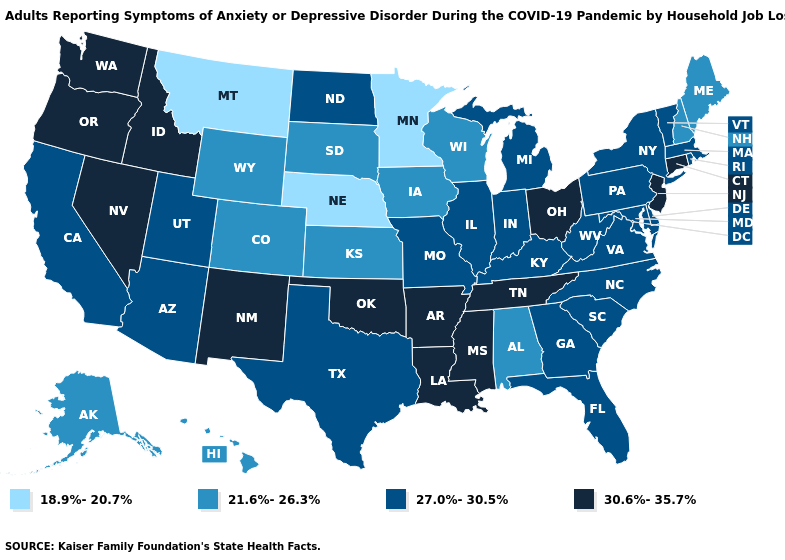Is the legend a continuous bar?
Write a very short answer. No. Name the states that have a value in the range 30.6%-35.7%?
Short answer required. Arkansas, Connecticut, Idaho, Louisiana, Mississippi, Nevada, New Jersey, New Mexico, Ohio, Oklahoma, Oregon, Tennessee, Washington. Does Oklahoma have the same value as Hawaii?
Give a very brief answer. No. How many symbols are there in the legend?
Be succinct. 4. Does Arkansas have a higher value than Kentucky?
Write a very short answer. Yes. Among the states that border Iowa , which have the highest value?
Give a very brief answer. Illinois, Missouri. Which states have the highest value in the USA?
Answer briefly. Arkansas, Connecticut, Idaho, Louisiana, Mississippi, Nevada, New Jersey, New Mexico, Ohio, Oklahoma, Oregon, Tennessee, Washington. Name the states that have a value in the range 18.9%-20.7%?
Concise answer only. Minnesota, Montana, Nebraska. Does Mississippi have the highest value in the USA?
Concise answer only. Yes. What is the highest value in states that border Kentucky?
Give a very brief answer. 30.6%-35.7%. Among the states that border Louisiana , does Texas have the highest value?
Give a very brief answer. No. What is the highest value in the South ?
Write a very short answer. 30.6%-35.7%. Among the states that border Louisiana , does Arkansas have the lowest value?
Be succinct. No. What is the value of Alaska?
Answer briefly. 21.6%-26.3%. What is the value of Vermont?
Write a very short answer. 27.0%-30.5%. 